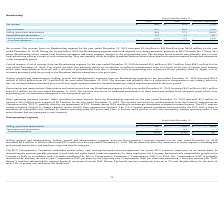According to Hc2 Holdings's financial document, What was the net revenue for the year ended December 31, 2019? According to the financial document, $41.8 million. The relevant text states: "ended December 31, 2019 decreased $3.6 million to $41.8 million from $45.4 million for the year ended December 31, 2018. During the second half of 2018, the Broadca..." Also, What was the selling, general and administrative expense for the year ended December 31, 2019? According to the financial document, $26.4 million. The relevant text states: "ended December 31, 2019 decreased $10.9 million to $26.4 million from $37.3 million for the year ended December 31, 2018. The decrease was primarily due to a reducti..." Also, What was the cost of revenue for the year ended December 31, 2019? According to the financial document, $23.5 million. The relevant text states: "ended December 31, 2019 decreased $5.0 million to $23.5 million from $28.5 million for the year ended December 31, 2018. The overall decrease was primarily driven b..." Also, can you calculate: What was the percentage change in the net revenue from 2018 to 2019? To answer this question, I need to perform calculations using the financial data. The calculation is: 41.8 / 45.4 - 1, which equals -7.93 (percentage). This is based on the information: "Net revenue $ 41.8 $ 45.4 $ (3.6) Net revenue $ 41.8 $ 45.4 $ (3.6)..." The key data points involved are: 41.8, 45.4. Also, can you calculate: What was the average cost of revenue for 2018 and 2019? To answer this question, I need to perform calculations using the financial data. The calculation is: (23.5 + 28.5) / 2, which equals 26 (in millions). This is based on the information: "Cost of revenue 23.5 28.5 (5.0) Cost of revenue 23.5 28.5 (5.0)..." The key data points involved are: 23.5, 28.5. Also, can you calculate: What is the percentage change in the Depreciation and amortization from 2018 to 2019? To answer this question, I need to perform calculations using the financial data. The calculation is: 6.3 / 3.3 - 1, which equals 90.91 (percentage). This is based on the information: "Depreciation and amortization 6.3 3.3 3.0 Depreciation and amortization 6.3 3.3 3.0..." The key data points involved are: 3.3, 6.3. 